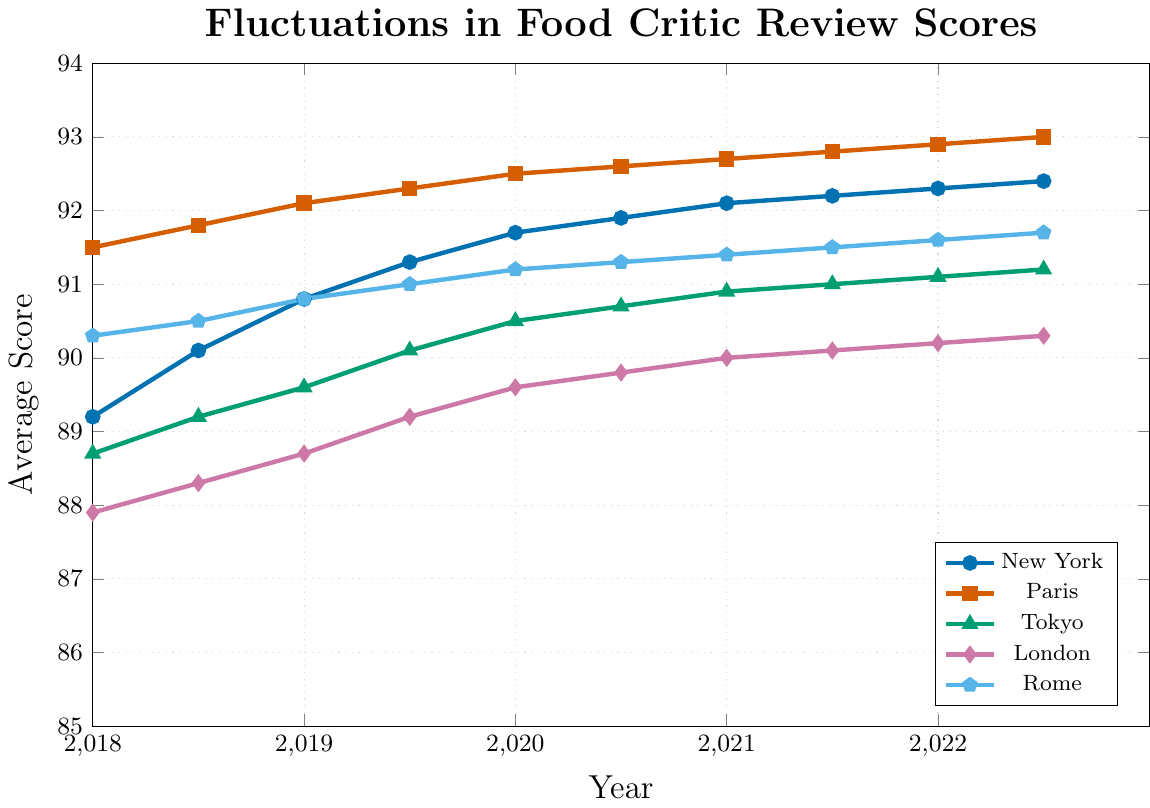Which city saw the highest review score in 2022? By tracing the review scores for each city in the year 2022, we can see that Paris has the highest score of 92.9 among all the cities.
Answer: Paris How did the scores of New York change from 2018 to 2022? The score of New York in 2018 was 89.2, and it increased to 92.3 by 2022. To see the change, we subtract 89.2 from 92.3, which gives 3.1. This shows an overall increase of 3.1.
Answer: Increased by 3.1 Which two cities had the closest review scores in 2019.5? By comparing the review scores of all cities in 2019.5, New York (91.3) and Paris (92.3) are the closest, with a difference of 1.0.
Answer: New York and Paris Between 2018 and 2022.5, did any city show a consistent upward trend in their scores? Observing the scores for each city from 2018 to 2022.5, all cities show a consistent increase without any drop in values during the period. Thus, every city's scores have consistently increased.
Answer: Yes, all cities At what year did Tokyo surpass a score of 90? To find out when Tokyo surpassed a score of 90, we observe that its score crosses 90 at 2019.5 when the score becomes 90.1.
Answer: 2019.5 Which city experienced the smallest increase in its review scores from 2018 to 2022.5? Examining the scores, we can calculate the increase for each city: New York (3.2), Paris (1.5), Tokyo (2.5), London (2.4), and Rome (1.4). Therefore, Rome experienced the smallest increase of 1.4.
Answer: Rome What is the average review score of all cities in 2020? To calculate the average score in 2020, we sum the scores of all cities (New York 91.7, Paris 92.5, Tokyo 90.5, London 89.6, Rome 91.2) to get a total of 455.5, and divide it by 5. Thus, 455.5 / 5 = 91.1.
Answer: 91.1 Which city had the sharpest increase in scores between 2018 and 2018.5? To determine this, we subtract the 2018 scores from 2018.5 scores for all cities: New York (0.9), Paris (0.3), Tokyo (0.5), London (0.4), and Rome (0.2). New York experienced the sharpest increase with a difference of 0.9.
Answer: New York 